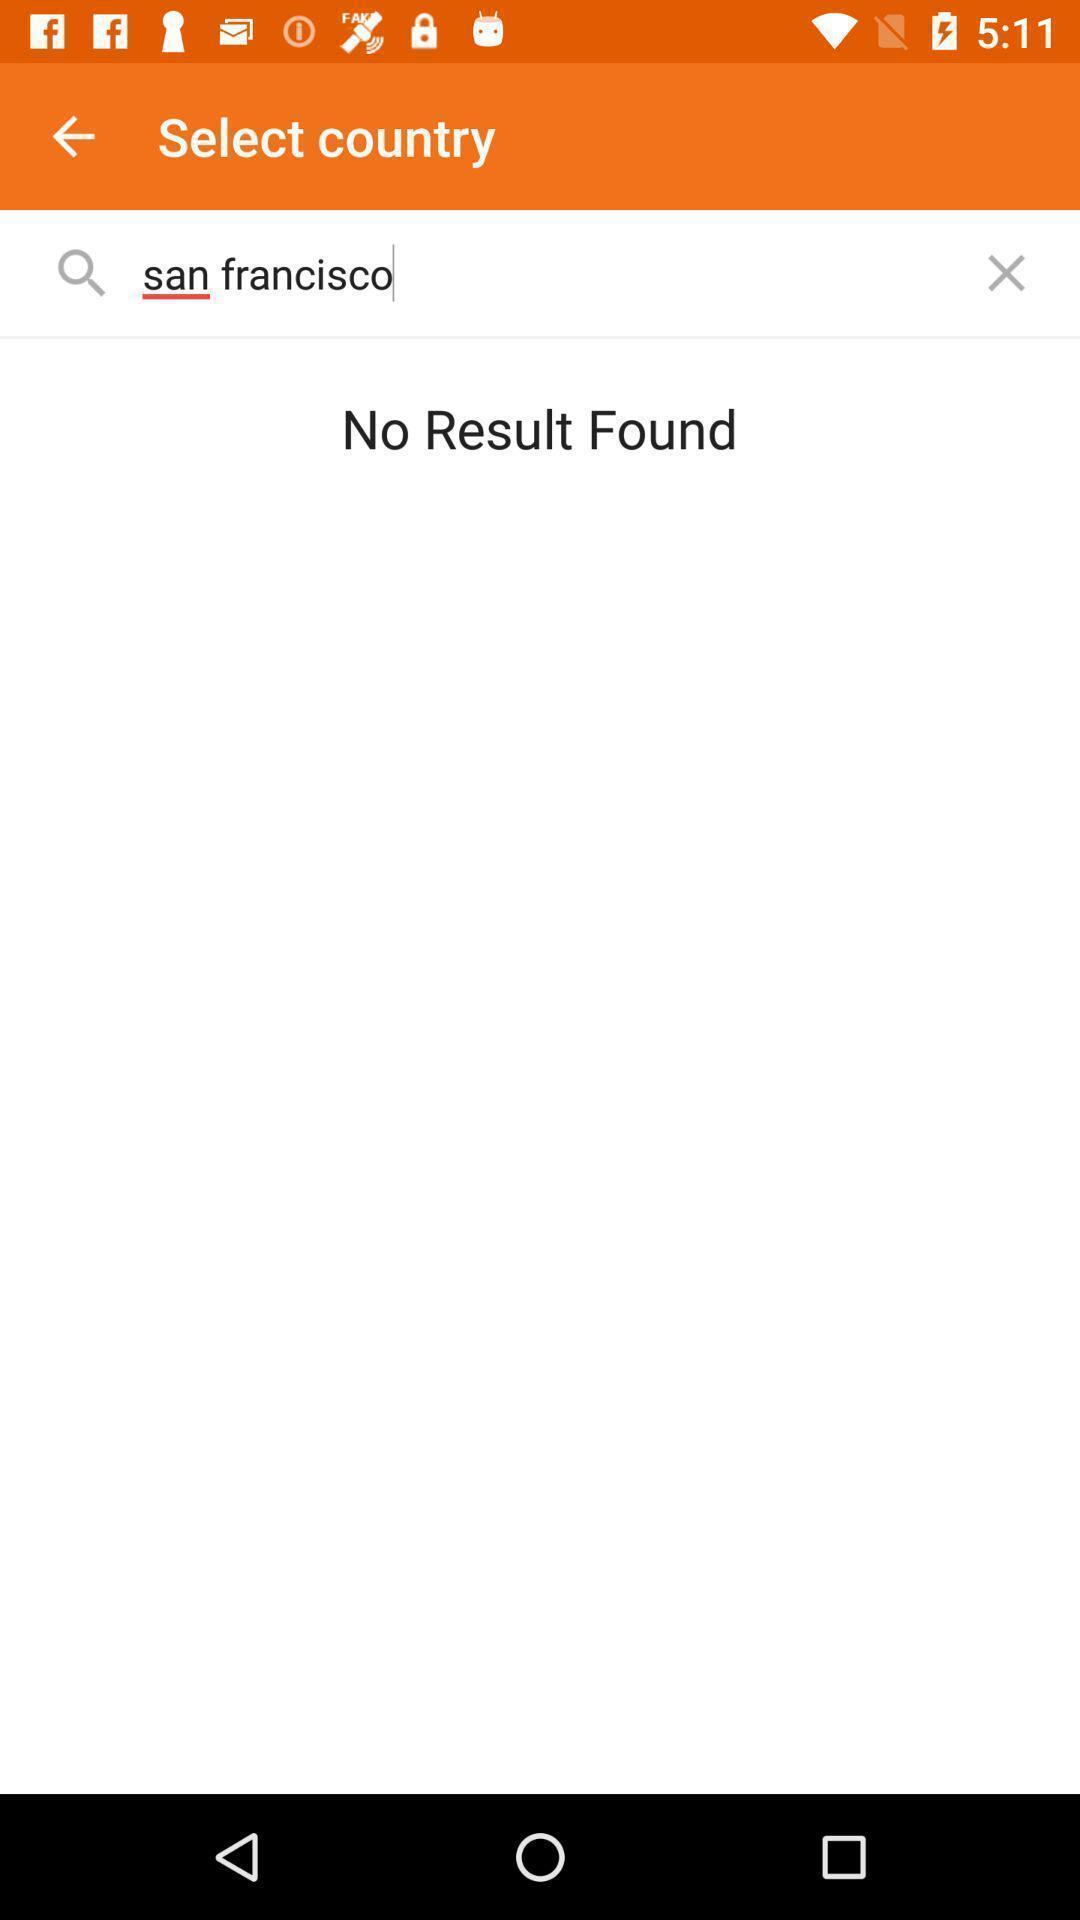Tell me about the visual elements in this screen capture. Screen shows to search select a country. 